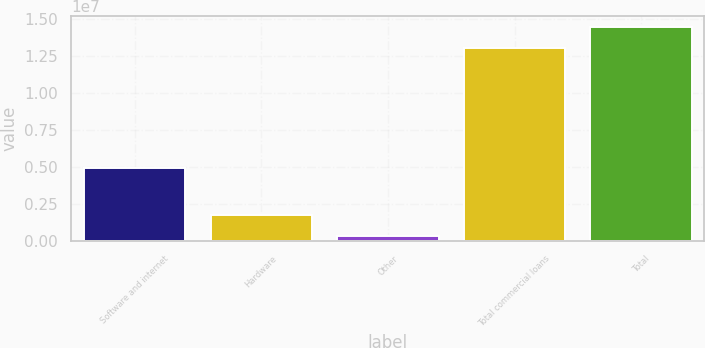<chart> <loc_0><loc_0><loc_500><loc_500><bar_chart><fcel>Software and internet<fcel>Hardware<fcel>Other<fcel>Total commercial loans<fcel>Total<nl><fcel>4.92139e+06<fcel>1.75195e+06<fcel>352595<fcel>1.30678e+07<fcel>1.44672e+07<nl></chart> 